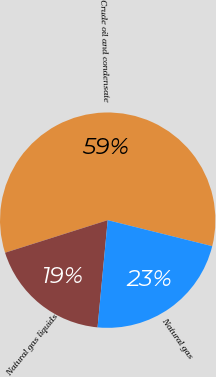<chart> <loc_0><loc_0><loc_500><loc_500><pie_chart><fcel>Crude oil and condensate<fcel>Natural gas liquids<fcel>Natural gas<nl><fcel>58.77%<fcel>18.61%<fcel>22.62%<nl></chart> 